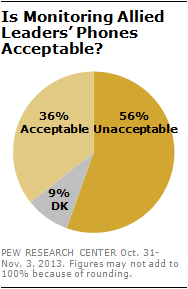Draw attention to some important aspects in this diagram. I have determined that the color of DK is gray. The percentage of acceptable and unacceptable elements can be determined through a scientific analysis, with the difference between the two being 20... 